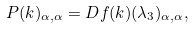<formula> <loc_0><loc_0><loc_500><loc_500>P ( { k } ) _ { \alpha , \alpha } = D f ( { k } ) ( \lambda _ { 3 } ) _ { \alpha , \alpha } ,</formula> 